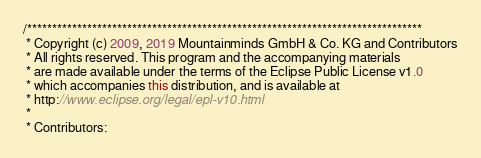Convert code to text. <code><loc_0><loc_0><loc_500><loc_500><_Java_>/*******************************************************************************
 * Copyright (c) 2009, 2019 Mountainminds GmbH & Co. KG and Contributors
 * All rights reserved. This program and the accompanying materials
 * are made available under the terms of the Eclipse Public License v1.0
 * which accompanies this distribution, and is available at
 * http://www.eclipse.org/legal/epl-v10.html
 *
 * Contributors:</code> 